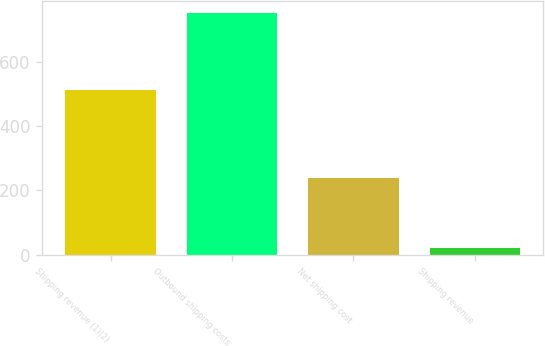Convert chart. <chart><loc_0><loc_0><loc_500><loc_500><bar_chart><fcel>Shipping revenue (1)(2)<fcel>Outbound shipping costs<fcel>Net shipping cost<fcel>Shipping revenue<nl><fcel>511<fcel>750<fcel>239<fcel>22<nl></chart> 